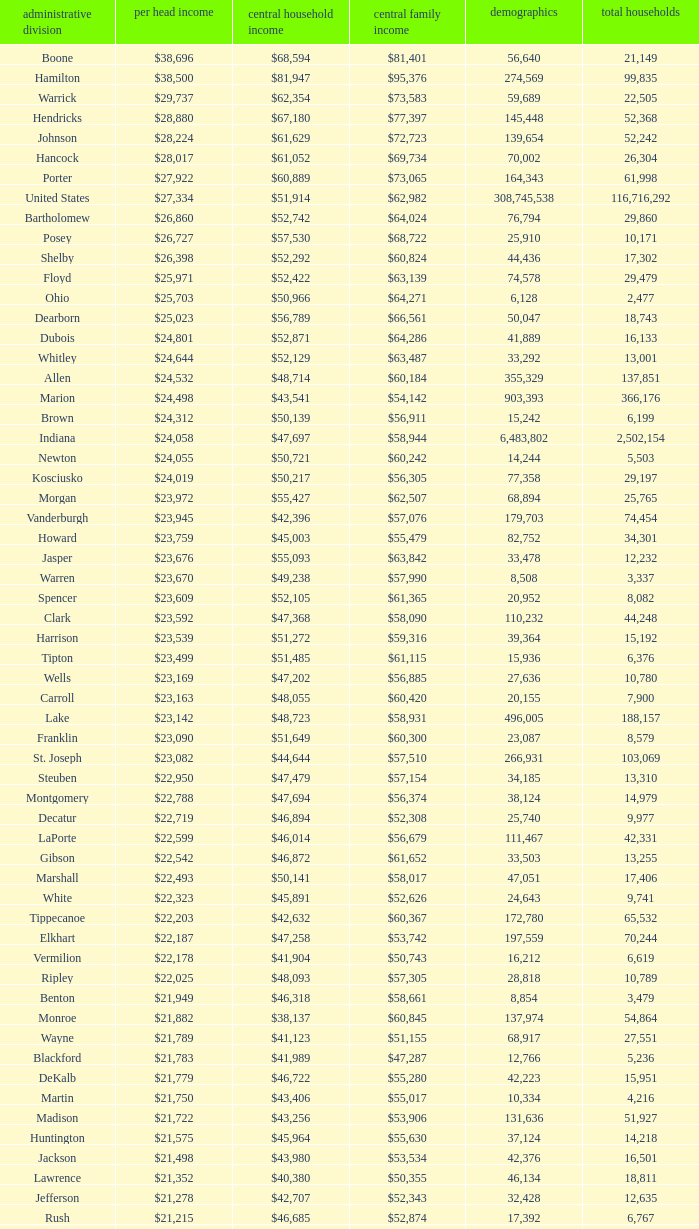What County has a Median household income of $46,872? Gibson. 